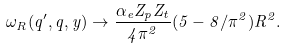Convert formula to latex. <formula><loc_0><loc_0><loc_500><loc_500>\omega _ { R } ( q ^ { \prime } , q , y ) \to \frac { \alpha _ { e } Z _ { p } Z _ { t } } { 4 \pi ^ { 2 } } ( 5 - 8 / \pi ^ { 2 } ) R ^ { 2 } .</formula> 